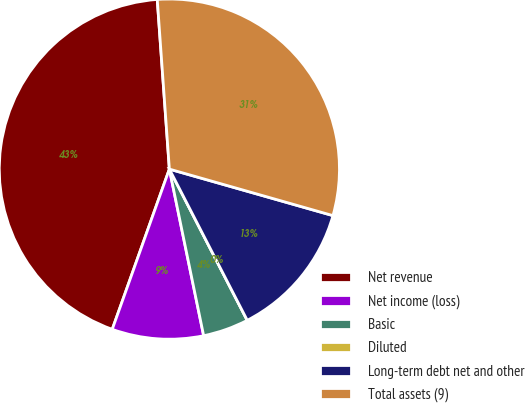Convert chart to OTSL. <chart><loc_0><loc_0><loc_500><loc_500><pie_chart><fcel>Net revenue<fcel>Net income (loss)<fcel>Basic<fcel>Diluted<fcel>Long-term debt net and other<fcel>Total assets (9)<nl><fcel>43.41%<fcel>8.68%<fcel>4.34%<fcel>0.0%<fcel>13.02%<fcel>30.54%<nl></chart> 